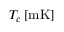Convert formula to latex. <formula><loc_0><loc_0><loc_500><loc_500>T _ { c } \, [ m K ]</formula> 